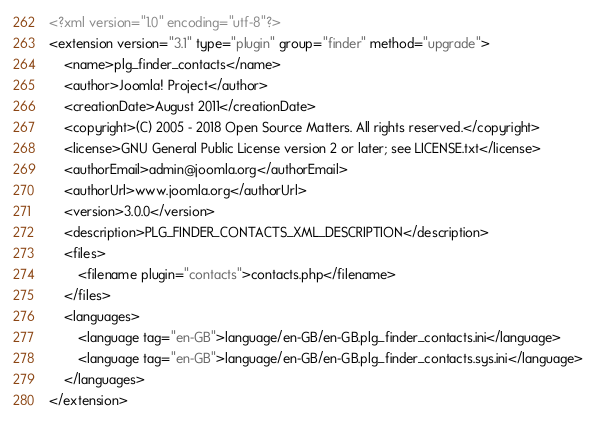Convert code to text. <code><loc_0><loc_0><loc_500><loc_500><_XML_><?xml version="1.0" encoding="utf-8"?>
<extension version="3.1" type="plugin" group="finder" method="upgrade">
	<name>plg_finder_contacts</name>
	<author>Joomla! Project</author>
	<creationDate>August 2011</creationDate>
	<copyright>(C) 2005 - 2018 Open Source Matters. All rights reserved.</copyright>
	<license>GNU General Public License version 2 or later; see LICENSE.txt</license>
	<authorEmail>admin@joomla.org</authorEmail>
	<authorUrl>www.joomla.org</authorUrl>
	<version>3.0.0</version>
	<description>PLG_FINDER_CONTACTS_XML_DESCRIPTION</description>
	<files>
		<filename plugin="contacts">contacts.php</filename>
	</files>
	<languages>
		<language tag="en-GB">language/en-GB/en-GB.plg_finder_contacts.ini</language>
		<language tag="en-GB">language/en-GB/en-GB.plg_finder_contacts.sys.ini</language>
	</languages>
</extension>
</code> 